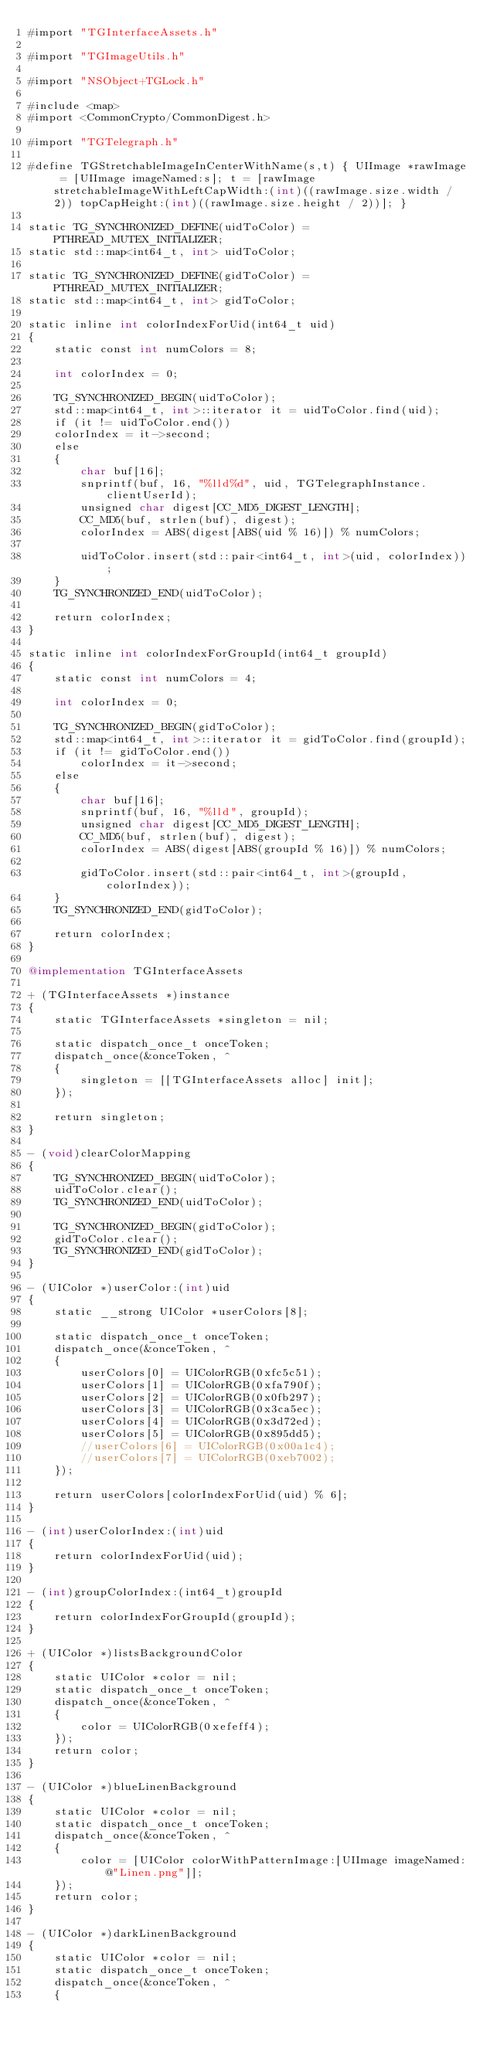<code> <loc_0><loc_0><loc_500><loc_500><_ObjectiveC_>#import "TGInterfaceAssets.h"

#import "TGImageUtils.h"

#import "NSObject+TGLock.h"

#include <map>
#import <CommonCrypto/CommonDigest.h>

#import "TGTelegraph.h"

#define TGStretchableImageInCenterWithName(s,t) { UIImage *rawImage = [UIImage imageNamed:s]; t = [rawImage stretchableImageWithLeftCapWidth:(int)((rawImage.size.width / 2)) topCapHeight:(int)((rawImage.size.height / 2))]; }

static TG_SYNCHRONIZED_DEFINE(uidToColor) = PTHREAD_MUTEX_INITIALIZER;
static std::map<int64_t, int> uidToColor;

static TG_SYNCHRONIZED_DEFINE(gidToColor) = PTHREAD_MUTEX_INITIALIZER;
static std::map<int64_t, int> gidToColor;

static inline int colorIndexForUid(int64_t uid)
{
    static const int numColors = 8;

    int colorIndex = 0;

    TG_SYNCHRONIZED_BEGIN(uidToColor);
    std::map<int64_t, int>::iterator it = uidToColor.find(uid);
    if (it != uidToColor.end())
    colorIndex = it->second;
    else
    {
        char buf[16];
        snprintf(buf, 16, "%lld%d", uid, TGTelegraphInstance.clientUserId);
        unsigned char digest[CC_MD5_DIGEST_LENGTH];
        CC_MD5(buf, strlen(buf), digest);
        colorIndex = ABS(digest[ABS(uid % 16)]) % numColors;
        
        uidToColor.insert(std::pair<int64_t, int>(uid, colorIndex));
    }
    TG_SYNCHRONIZED_END(uidToColor);
    
    return colorIndex;
}

static inline int colorIndexForGroupId(int64_t groupId)
{
    static const int numColors = 4;
    
    int colorIndex = 0;
    
    TG_SYNCHRONIZED_BEGIN(gidToColor);
    std::map<int64_t, int>::iterator it = gidToColor.find(groupId);
    if (it != gidToColor.end())
        colorIndex = it->second;
    else
    {
        char buf[16];
        snprintf(buf, 16, "%lld", groupId);
        unsigned char digest[CC_MD5_DIGEST_LENGTH];
        CC_MD5(buf, strlen(buf), digest);
        colorIndex = ABS(digest[ABS(groupId % 16)]) % numColors;
        
        gidToColor.insert(std::pair<int64_t, int>(groupId, colorIndex));
    }
    TG_SYNCHRONIZED_END(gidToColor);
    
    return colorIndex;
}

@implementation TGInterfaceAssets

+ (TGInterfaceAssets *)instance
{
    static TGInterfaceAssets *singleton = nil;
    
    static dispatch_once_t onceToken;
    dispatch_once(&onceToken, ^
    {
        singleton = [[TGInterfaceAssets alloc] init];
    });
    
    return singleton;
}

- (void)clearColorMapping
{
    TG_SYNCHRONIZED_BEGIN(uidToColor);
    uidToColor.clear();
    TG_SYNCHRONIZED_END(uidToColor);
    
    TG_SYNCHRONIZED_BEGIN(gidToColor);
    gidToColor.clear();
    TG_SYNCHRONIZED_END(gidToColor);
}

- (UIColor *)userColor:(int)uid
{
    static __strong UIColor *userColors[8];
    
    static dispatch_once_t onceToken;
    dispatch_once(&onceToken, ^
    {
        userColors[0] = UIColorRGB(0xfc5c51);
        userColors[1] = UIColorRGB(0xfa790f);
        userColors[2] = UIColorRGB(0x0fb297);
        userColors[3] = UIColorRGB(0x3ca5ec);
        userColors[4] = UIColorRGB(0x3d72ed);
        userColors[5] = UIColorRGB(0x895dd5);
        //userColors[6] = UIColorRGB(0x00a1c4);
        //userColors[7] = UIColorRGB(0xeb7002);
    });
    
    return userColors[colorIndexForUid(uid) % 6];
}

- (int)userColorIndex:(int)uid
{
    return colorIndexForUid(uid);
}

- (int)groupColorIndex:(int64_t)groupId
{
    return colorIndexForGroupId(groupId);
}

+ (UIColor *)listsBackgroundColor
{
    static UIColor *color = nil;
    static dispatch_once_t onceToken;
    dispatch_once(&onceToken, ^
    {
        color = UIColorRGB(0xefeff4);
    });
    return color;
}

- (UIColor *)blueLinenBackground
{
    static UIColor *color = nil;
    static dispatch_once_t onceToken;
    dispatch_once(&onceToken, ^
    {
        color = [UIColor colorWithPatternImage:[UIImage imageNamed:@"Linen.png"]];
    });
    return color;
}

- (UIColor *)darkLinenBackground
{
    static UIColor *color = nil;
    static dispatch_once_t onceToken;
    dispatch_once(&onceToken, ^
    {</code> 